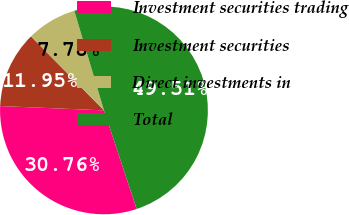Convert chart to OTSL. <chart><loc_0><loc_0><loc_500><loc_500><pie_chart><fcel>Investment securities trading<fcel>Investment securities<fcel>Direct investments in<fcel>Total<nl><fcel>30.76%<fcel>11.95%<fcel>7.78%<fcel>49.51%<nl></chart> 